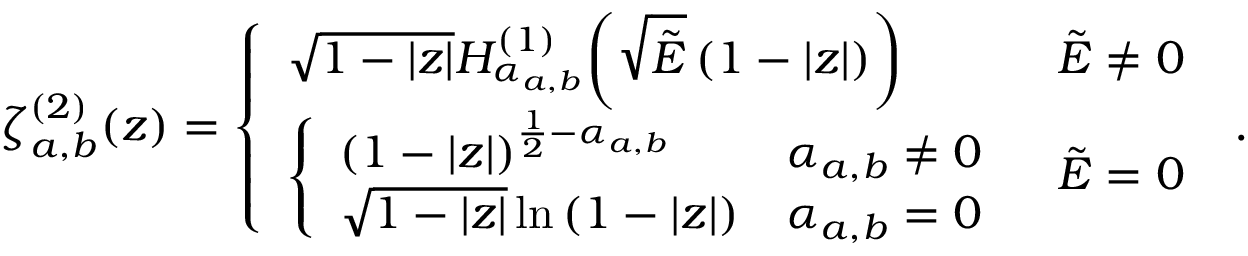<formula> <loc_0><loc_0><loc_500><loc_500>\zeta _ { a , b } ^ { ( 2 ) } ( z ) = \left \{ \begin{array} { l l } { \sqrt { 1 - | z | } H _ { \alpha _ { a , b } } ^ { ( 1 ) } \, \left ( \sqrt { \tilde { E } } \left ( 1 - | z | \right ) \right ) } & { \tilde { E } \neq 0 } \\ { \left \{ \begin{array} { l l } { { \left ( 1 - | z | \right ) } ^ { \frac { 1 } { 2 } - { \alpha _ { a , b } } } } & { { \alpha _ { a , b } } \neq 0 } \\ { \sqrt { 1 - | z | } \ln { \left ( 1 - | z | \right ) } } & { { \alpha _ { a , b } } = 0 } \end{array} } & { \tilde { E } = 0 } \end{array} \, .</formula> 